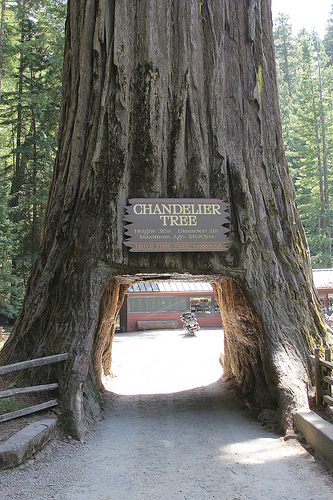<image>
Is the hole under the tree? Yes. The hole is positioned underneath the tree, with the tree above it in the vertical space. 